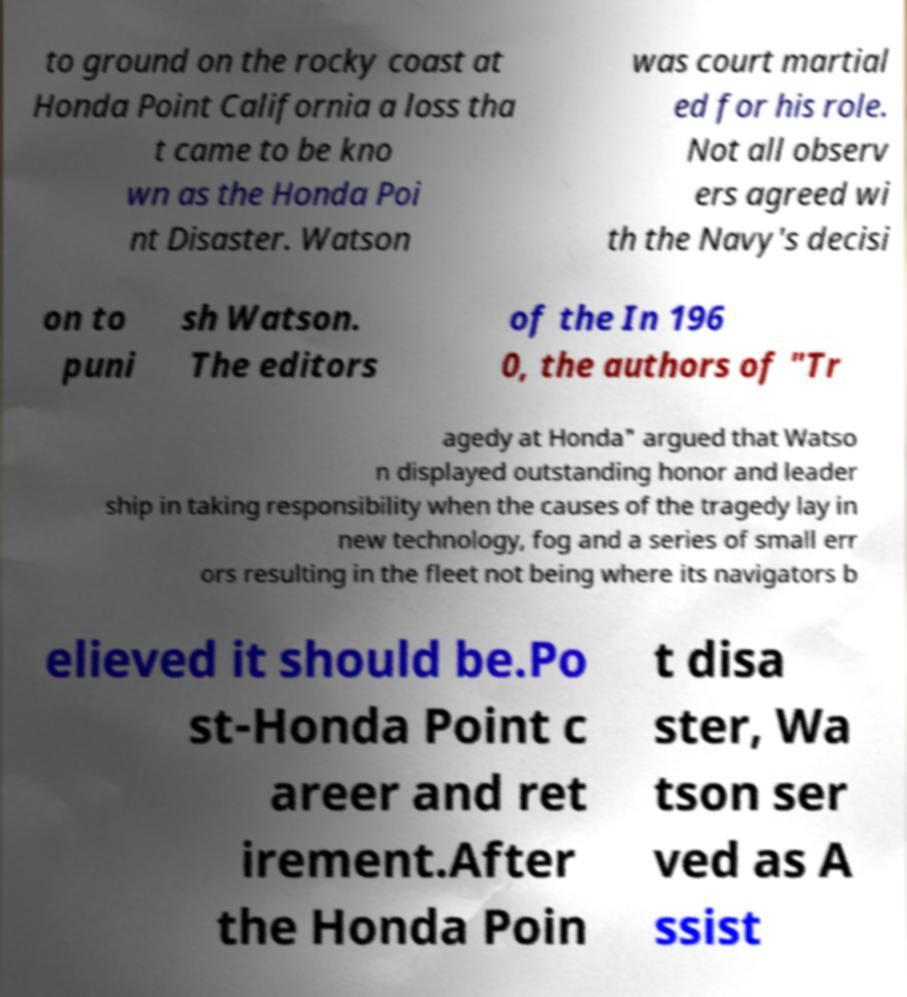Could you extract and type out the text from this image? to ground on the rocky coast at Honda Point California a loss tha t came to be kno wn as the Honda Poi nt Disaster. Watson was court martial ed for his role. Not all observ ers agreed wi th the Navy's decisi on to puni sh Watson. The editors of the In 196 0, the authors of "Tr agedy at Honda" argued that Watso n displayed outstanding honor and leader ship in taking responsibility when the causes of the tragedy lay in new technology, fog and a series of small err ors resulting in the fleet not being where its navigators b elieved it should be.Po st-Honda Point c areer and ret irement.After the Honda Poin t disa ster, Wa tson ser ved as A ssist 